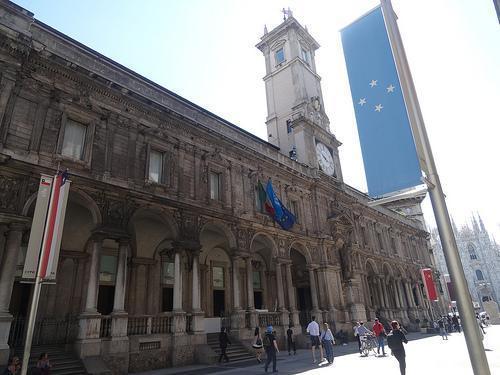How many buildings?
Give a very brief answer. 2. How many flags on the building in this picture are blue with yellow stars?
Give a very brief answer. 1. 